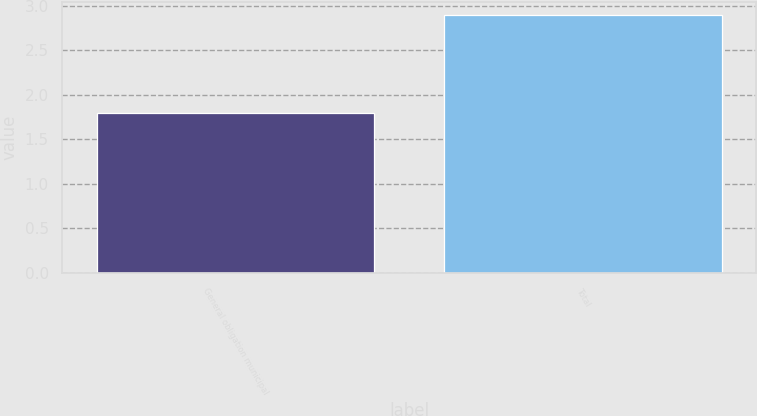Convert chart. <chart><loc_0><loc_0><loc_500><loc_500><bar_chart><fcel>General obligation municipal<fcel>Total<nl><fcel>1.8<fcel>2.9<nl></chart> 